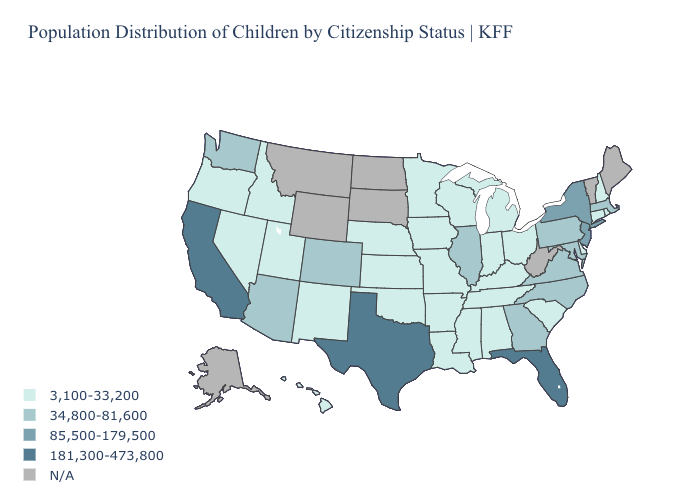Which states have the lowest value in the USA?
Give a very brief answer. Alabama, Arkansas, Connecticut, Delaware, Hawaii, Idaho, Indiana, Iowa, Kansas, Kentucky, Louisiana, Michigan, Minnesota, Mississippi, Missouri, Nebraska, Nevada, New Hampshire, New Mexico, Ohio, Oklahoma, Oregon, Rhode Island, South Carolina, Tennessee, Utah, Wisconsin. What is the lowest value in the West?
Concise answer only. 3,100-33,200. Does Utah have the lowest value in the USA?
Concise answer only. Yes. What is the highest value in states that border South Dakota?
Short answer required. 3,100-33,200. Which states have the highest value in the USA?
Short answer required. California, Florida, Texas. What is the value of Nebraska?
Quick response, please. 3,100-33,200. Name the states that have a value in the range 34,800-81,600?
Answer briefly. Arizona, Colorado, Georgia, Illinois, Maryland, Massachusetts, North Carolina, Pennsylvania, Virginia, Washington. Among the states that border Maryland , does Delaware have the lowest value?
Give a very brief answer. Yes. What is the value of South Dakota?
Write a very short answer. N/A. Which states hav the highest value in the West?
Short answer required. California. What is the value of Connecticut?
Be succinct. 3,100-33,200. Name the states that have a value in the range 34,800-81,600?
Be succinct. Arizona, Colorado, Georgia, Illinois, Maryland, Massachusetts, North Carolina, Pennsylvania, Virginia, Washington. 